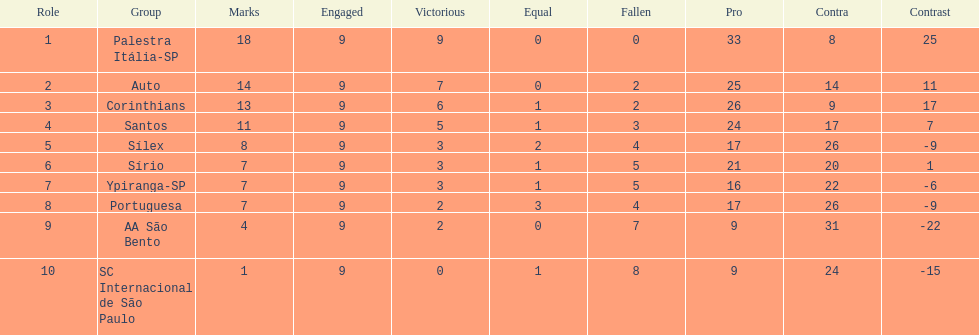How many teams had more points than silex? 4. 